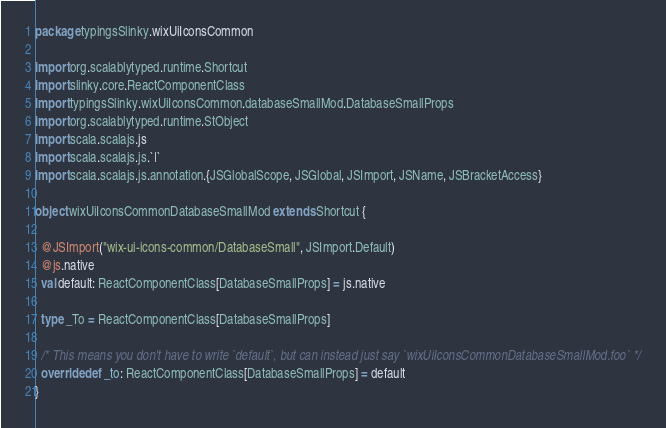<code> <loc_0><loc_0><loc_500><loc_500><_Scala_>package typingsSlinky.wixUiIconsCommon

import org.scalablytyped.runtime.Shortcut
import slinky.core.ReactComponentClass
import typingsSlinky.wixUiIconsCommon.databaseSmallMod.DatabaseSmallProps
import org.scalablytyped.runtime.StObject
import scala.scalajs.js
import scala.scalajs.js.`|`
import scala.scalajs.js.annotation.{JSGlobalScope, JSGlobal, JSImport, JSName, JSBracketAccess}

object wixUiIconsCommonDatabaseSmallMod extends Shortcut {
  
  @JSImport("wix-ui-icons-common/DatabaseSmall", JSImport.Default)
  @js.native
  val default: ReactComponentClass[DatabaseSmallProps] = js.native
  
  type _To = ReactComponentClass[DatabaseSmallProps]
  
  /* This means you don't have to write `default`, but can instead just say `wixUiIconsCommonDatabaseSmallMod.foo` */
  override def _to: ReactComponentClass[DatabaseSmallProps] = default
}
</code> 